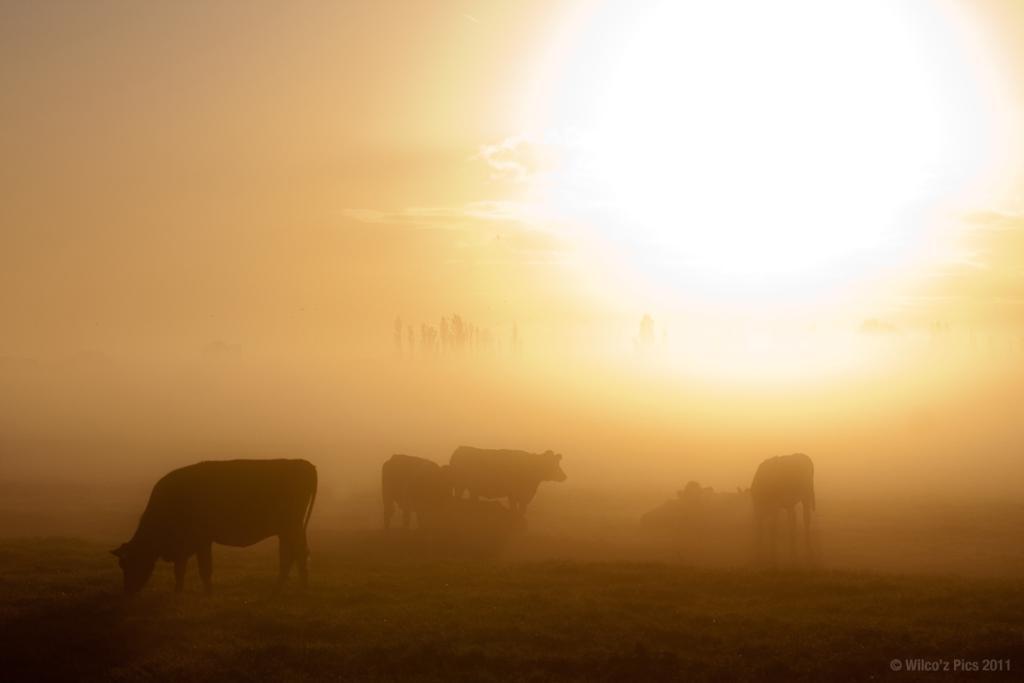In one or two sentences, can you explain what this image depicts? In this picture I can see animals on the surface. I can see the sun. 